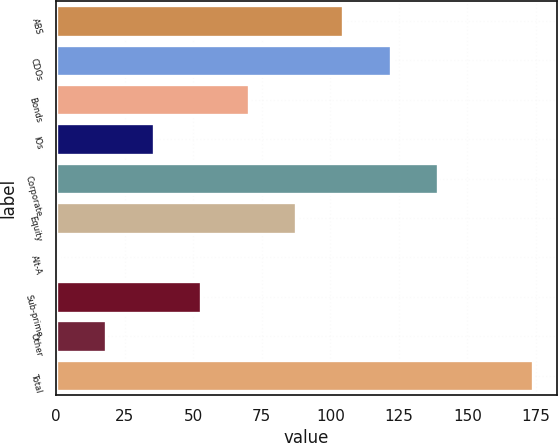Convert chart to OTSL. <chart><loc_0><loc_0><loc_500><loc_500><bar_chart><fcel>ABS<fcel>CDOs<fcel>Bonds<fcel>IOs<fcel>Corporate<fcel>Equity<fcel>Alt-A<fcel>Sub-prime<fcel>Other<fcel>Total<nl><fcel>104.8<fcel>122.1<fcel>70.2<fcel>35.6<fcel>139.4<fcel>87.5<fcel>1<fcel>52.9<fcel>18.3<fcel>174<nl></chart> 